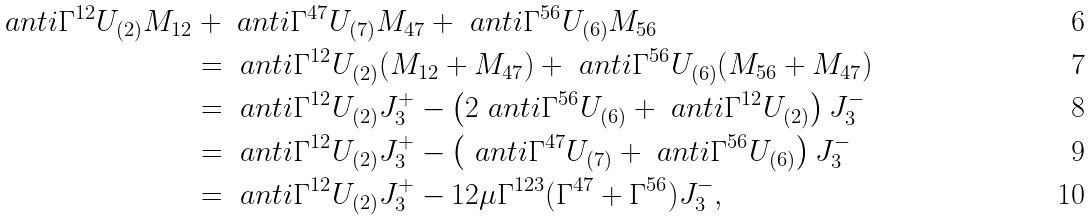<formula> <loc_0><loc_0><loc_500><loc_500>\ a n t i { \Gamma ^ { 1 2 } } { U _ { ( 2 ) } } M _ { 1 2 } & + \ a n t i { \Gamma ^ { 4 7 } } { U _ { ( 7 ) } } M _ { 4 7 } + \ a n t i { \Gamma ^ { 5 6 } } { U _ { ( 6 ) } } M _ { 5 6 } \\ & = \ a n t i { \Gamma ^ { 1 2 } } { U _ { ( 2 ) } } ( M _ { 1 2 } + M _ { 4 7 } ) + \ a n t i { \Gamma ^ { 5 6 } } { U _ { ( 6 ) } } ( M _ { 5 6 } + M _ { 4 7 } ) \\ & = \ a n t i { \Gamma ^ { 1 2 } } { U _ { ( 2 ) } } J ^ { + } _ { 3 } - \left ( 2 \ a n t i { \Gamma ^ { 5 6 } } { U _ { ( 6 ) } } + \ a n t i { \Gamma ^ { 1 2 } } { U _ { ( 2 ) } } \right ) J ^ { - } _ { 3 } \\ & = \ a n t i { \Gamma ^ { 1 2 } } { U _ { ( 2 ) } } J ^ { + } _ { 3 } - \left ( \ a n t i { \Gamma ^ { 4 7 } } { U _ { ( 7 ) } } + \ a n t i { \Gamma ^ { 5 6 } } { U _ { ( 6 ) } } \right ) J ^ { - } _ { 3 } \\ & = \ a n t i { \Gamma ^ { 1 2 } } { U _ { ( 2 ) } } J ^ { + } _ { 3 } - 1 2 \mu \Gamma ^ { 1 2 3 } ( \Gamma ^ { 4 7 } + \Gamma ^ { 5 6 } ) J ^ { - } _ { 3 } ,</formula> 